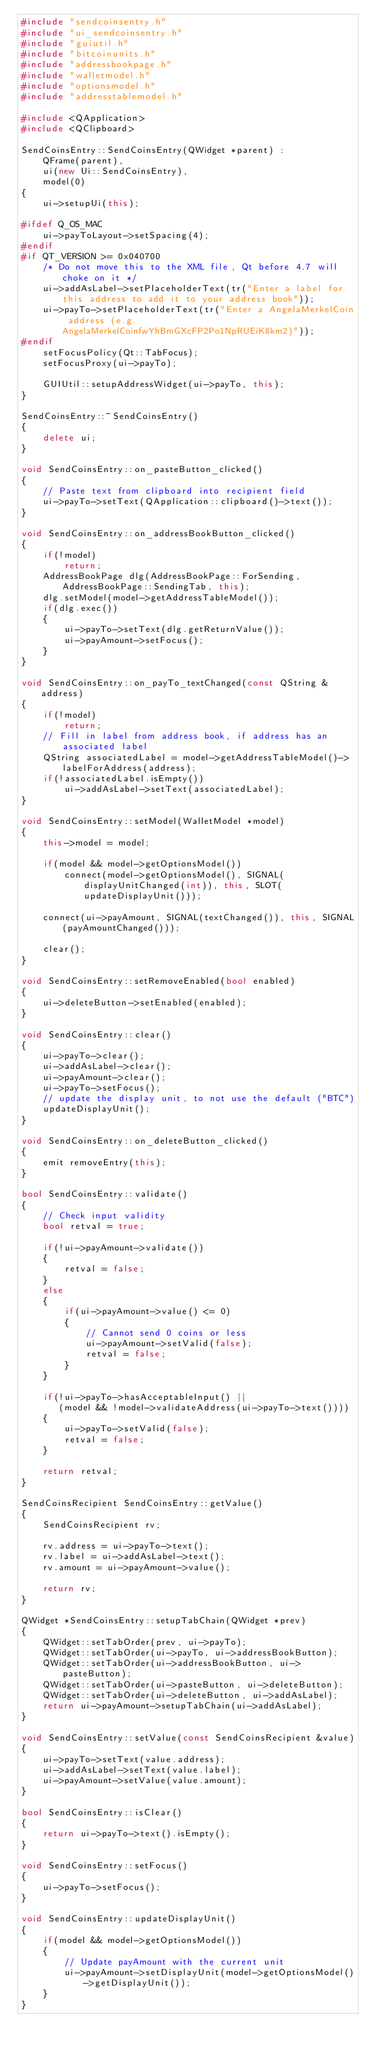<code> <loc_0><loc_0><loc_500><loc_500><_C++_>#include "sendcoinsentry.h"
#include "ui_sendcoinsentry.h"
#include "guiutil.h"
#include "bitcoinunits.h"
#include "addressbookpage.h"
#include "walletmodel.h"
#include "optionsmodel.h"
#include "addresstablemodel.h"

#include <QApplication>
#include <QClipboard>

SendCoinsEntry::SendCoinsEntry(QWidget *parent) :
    QFrame(parent),
    ui(new Ui::SendCoinsEntry),
    model(0)
{
    ui->setupUi(this);

#ifdef Q_OS_MAC
    ui->payToLayout->setSpacing(4);
#endif
#if QT_VERSION >= 0x040700
    /* Do not move this to the XML file, Qt before 4.7 will choke on it */
    ui->addAsLabel->setPlaceholderText(tr("Enter a label for this address to add it to your address book"));
    ui->payTo->setPlaceholderText(tr("Enter a AngelaMerkelCoin address (e.g. AngelaMerkelCoinfwYhBmGXcFP2Po1NpRUEiK8km2)"));
#endif
    setFocusPolicy(Qt::TabFocus);
    setFocusProxy(ui->payTo);

    GUIUtil::setupAddressWidget(ui->payTo, this);
}

SendCoinsEntry::~SendCoinsEntry()
{
    delete ui;
}

void SendCoinsEntry::on_pasteButton_clicked()
{
    // Paste text from clipboard into recipient field
    ui->payTo->setText(QApplication::clipboard()->text());
}

void SendCoinsEntry::on_addressBookButton_clicked()
{
    if(!model)
        return;
    AddressBookPage dlg(AddressBookPage::ForSending, AddressBookPage::SendingTab, this);
    dlg.setModel(model->getAddressTableModel());
    if(dlg.exec())
    {
        ui->payTo->setText(dlg.getReturnValue());
        ui->payAmount->setFocus();
    }
}

void SendCoinsEntry::on_payTo_textChanged(const QString &address)
{
    if(!model)
        return;
    // Fill in label from address book, if address has an associated label
    QString associatedLabel = model->getAddressTableModel()->labelForAddress(address);
    if(!associatedLabel.isEmpty())
        ui->addAsLabel->setText(associatedLabel);
}

void SendCoinsEntry::setModel(WalletModel *model)
{
    this->model = model;

    if(model && model->getOptionsModel())
        connect(model->getOptionsModel(), SIGNAL(displayUnitChanged(int)), this, SLOT(updateDisplayUnit()));

    connect(ui->payAmount, SIGNAL(textChanged()), this, SIGNAL(payAmountChanged()));

    clear();
}

void SendCoinsEntry::setRemoveEnabled(bool enabled)
{
    ui->deleteButton->setEnabled(enabled);
}

void SendCoinsEntry::clear()
{
    ui->payTo->clear();
    ui->addAsLabel->clear();
    ui->payAmount->clear();
    ui->payTo->setFocus();
    // update the display unit, to not use the default ("BTC")
    updateDisplayUnit();
}

void SendCoinsEntry::on_deleteButton_clicked()
{
    emit removeEntry(this);
}

bool SendCoinsEntry::validate()
{
    // Check input validity
    bool retval = true;

    if(!ui->payAmount->validate())
    {
        retval = false;
    }
    else
    {
        if(ui->payAmount->value() <= 0)
        {
            // Cannot send 0 coins or less
            ui->payAmount->setValid(false);
            retval = false;
        }
    }

    if(!ui->payTo->hasAcceptableInput() ||
       (model && !model->validateAddress(ui->payTo->text())))
    {
        ui->payTo->setValid(false);
        retval = false;
    }

    return retval;
}

SendCoinsRecipient SendCoinsEntry::getValue()
{
    SendCoinsRecipient rv;

    rv.address = ui->payTo->text();
    rv.label = ui->addAsLabel->text();
    rv.amount = ui->payAmount->value();

    return rv;
}

QWidget *SendCoinsEntry::setupTabChain(QWidget *prev)
{
    QWidget::setTabOrder(prev, ui->payTo);
    QWidget::setTabOrder(ui->payTo, ui->addressBookButton);
    QWidget::setTabOrder(ui->addressBookButton, ui->pasteButton);
    QWidget::setTabOrder(ui->pasteButton, ui->deleteButton);
    QWidget::setTabOrder(ui->deleteButton, ui->addAsLabel);
    return ui->payAmount->setupTabChain(ui->addAsLabel);
}

void SendCoinsEntry::setValue(const SendCoinsRecipient &value)
{
    ui->payTo->setText(value.address);
    ui->addAsLabel->setText(value.label);
    ui->payAmount->setValue(value.amount);
}

bool SendCoinsEntry::isClear()
{
    return ui->payTo->text().isEmpty();
}

void SendCoinsEntry::setFocus()
{
    ui->payTo->setFocus();
}

void SendCoinsEntry::updateDisplayUnit()
{
    if(model && model->getOptionsModel())
    {
        // Update payAmount with the current unit
        ui->payAmount->setDisplayUnit(model->getOptionsModel()->getDisplayUnit());
    }
}
</code> 